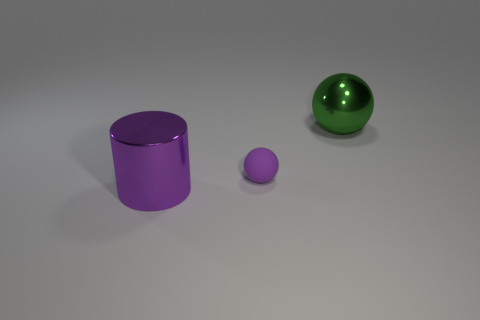Add 1 shiny cylinders. How many objects exist? 4 Subtract all purple balls. How many balls are left? 1 Subtract all balls. How many objects are left? 1 Subtract 0 brown cylinders. How many objects are left? 3 Subtract 1 cylinders. How many cylinders are left? 0 Subtract all red balls. Subtract all cyan cylinders. How many balls are left? 2 Subtract all gray spheres. How many green cylinders are left? 0 Subtract all green spheres. Subtract all tiny matte objects. How many objects are left? 1 Add 3 big purple objects. How many big purple objects are left? 4 Add 1 small things. How many small things exist? 2 